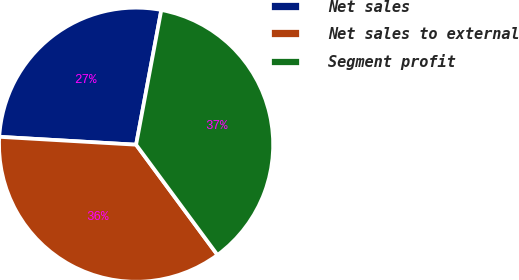Convert chart. <chart><loc_0><loc_0><loc_500><loc_500><pie_chart><fcel>Net sales<fcel>Net sales to external<fcel>Segment profit<nl><fcel>27.03%<fcel>36.04%<fcel>36.94%<nl></chart> 